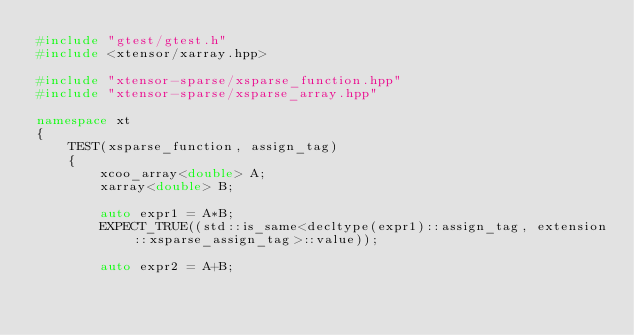<code> <loc_0><loc_0><loc_500><loc_500><_C++_>#include "gtest/gtest.h"
#include <xtensor/xarray.hpp>

#include "xtensor-sparse/xsparse_function.hpp"
#include "xtensor-sparse/xsparse_array.hpp"

namespace xt
{
    TEST(xsparse_function, assign_tag)
    {
        xcoo_array<double> A;
        xarray<double> B;

        auto expr1 = A*B;
        EXPECT_TRUE((std::is_same<decltype(expr1)::assign_tag, extension::xsparse_assign_tag>::value));

        auto expr2 = A+B;</code> 